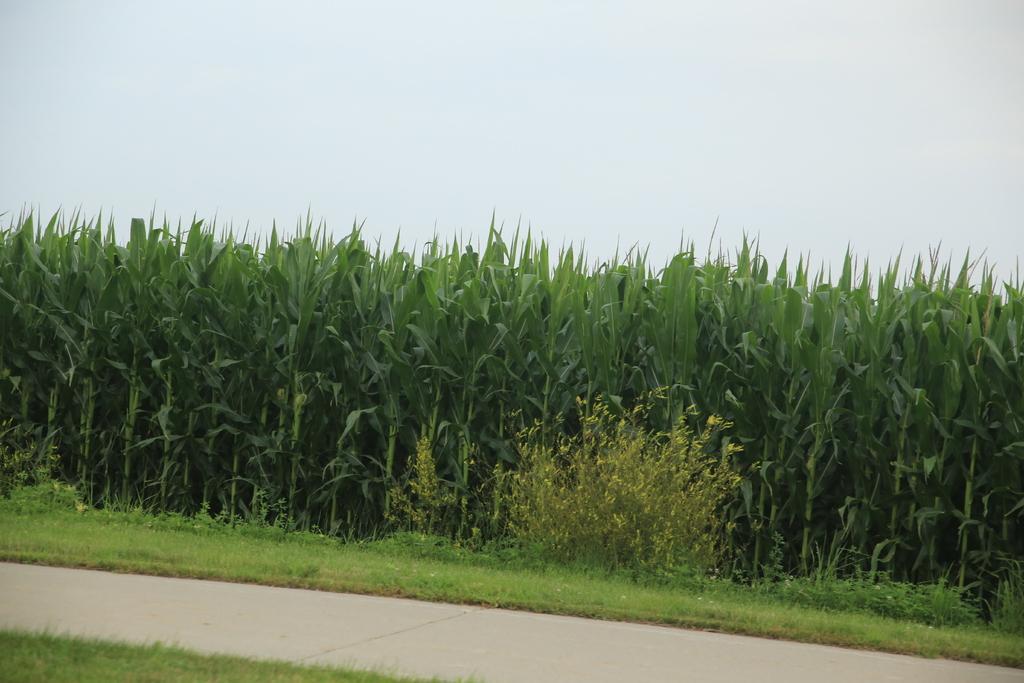How would you summarize this image in a sentence or two? In this image there is the sky truncated towards the top of the image, there are plants truncated, there is the grass truncated, there is grass truncated towards the bottom of the image. 